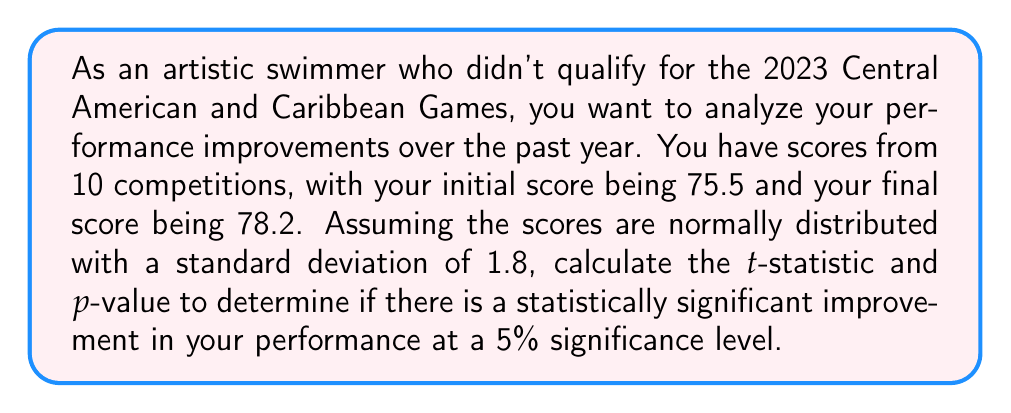Give your solution to this math problem. To determine if there is a statistically significant improvement in performance, we'll use a paired t-test. Here's how to approach this problem:

1. Calculate the mean difference ($\bar{d}$) between the final and initial scores:
   $\bar{d} = 78.2 - 75.5 = 2.7$

2. We're given the standard deviation ($s$) of 1.8 and the sample size ($n$) of 10.

3. Calculate the standard error (SE) of the mean difference:
   $SE = \frac{s}{\sqrt{n}} = \frac{1.8}{\sqrt{10}} = 0.5692$

4. Calculate the t-statistic:
   $t = \frac{\bar{d}}{SE} = \frac{2.7}{0.5692} = 4.7435$

5. Determine the degrees of freedom (df):
   $df = n - 1 = 10 - 1 = 9$

6. Find the critical t-value for a two-tailed test at 5% significance level with 9 df:
   $t_{critical} = \pm 2.262$

7. Calculate the p-value using the t-distribution with 9 df:
   $p-value = 2 \times P(T > 4.7435)$, where T follows a t-distribution with 9 df.
   Using a t-distribution calculator or table, we find:
   $p-value \approx 0.001$

8. Compare the t-statistic to the critical t-value and the p-value to the significance level:
   $|t| = 4.7435 > 2.262 = t_{critical}$
   $p-value = 0.001 < 0.05 = \alpha$

Therefore, we reject the null hypothesis and conclude that there is a statistically significant improvement in performance.
Answer: t-statistic: 4.7435
p-value: 0.001
There is a statistically significant improvement in performance at the 5% significance level. 